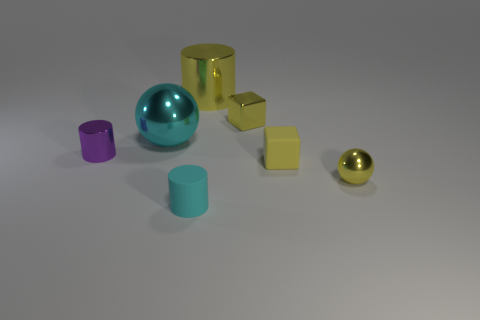The cyan thing behind the small rubber object that is in front of the metal sphere that is right of the cyan cylinder is what shape?
Keep it short and to the point. Sphere. What number of purple things are either metal things or small things?
Provide a succinct answer. 1. Are there the same number of small cylinders behind the cyan matte cylinder and small shiny spheres on the left side of the small yellow metal block?
Make the answer very short. No. There is a matte object that is left of the big yellow metal object; is it the same shape as the rubber thing on the right side of the big metal cylinder?
Your answer should be very brief. No. Is there any other thing that is the same shape as the small purple shiny thing?
Give a very brief answer. Yes. There is a big cyan object that is made of the same material as the big yellow cylinder; what is its shape?
Your answer should be compact. Sphere. Are there the same number of objects right of the big cyan metal sphere and cyan rubber objects?
Provide a short and direct response. No. Is the big object in front of the yellow metal cylinder made of the same material as the tiny yellow block in front of the purple cylinder?
Your answer should be compact. No. What shape is the yellow shiny thing in front of the tiny shiny object that is to the left of the small cyan rubber cylinder?
Your answer should be compact. Sphere. There is a large object that is the same material as the big cyan sphere; what color is it?
Provide a succinct answer. Yellow. 